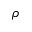<formula> <loc_0><loc_0><loc_500><loc_500>\rho</formula> 